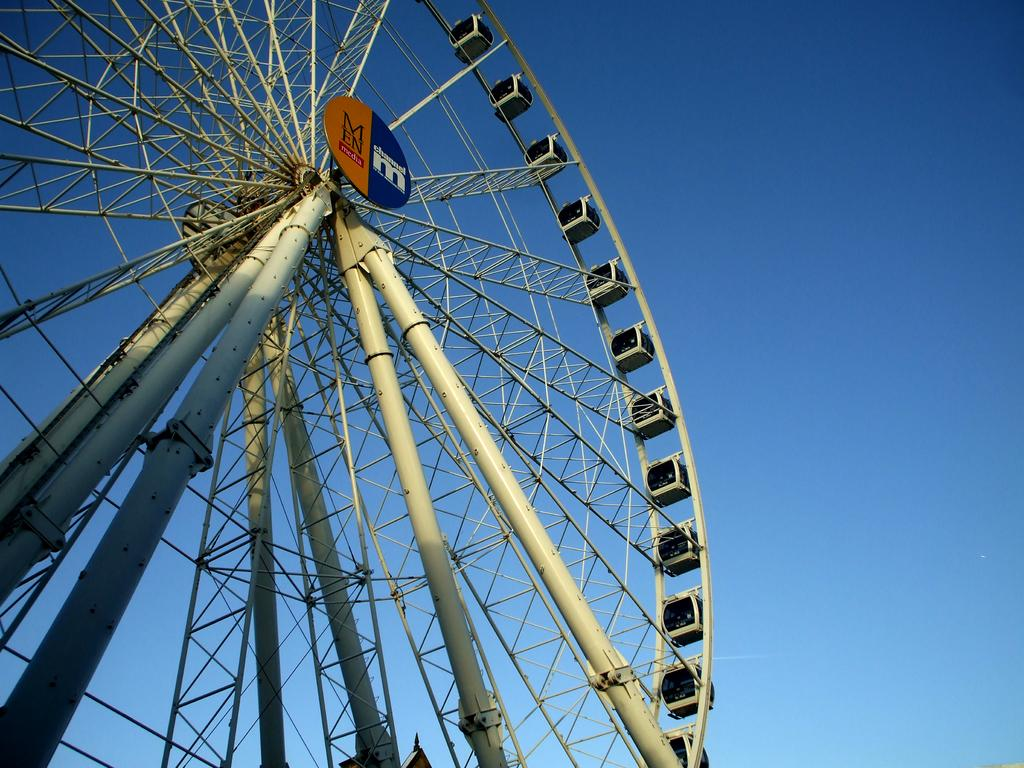What is the main subject of the image? The main subject of the image is a Ferris wheel. What type of sea creature can be seen swimming near the Ferris wheel in the image? There is no sea creature present in the image, as it features a Ferris wheel and no reference to a sea or any creatures. 